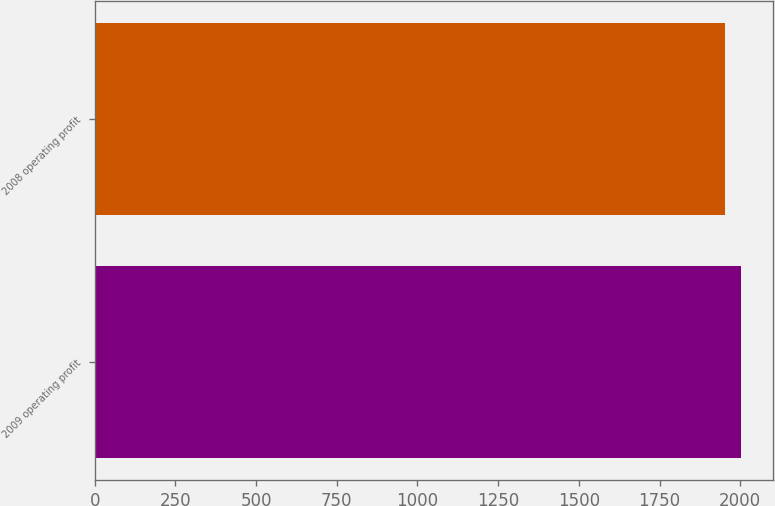<chart> <loc_0><loc_0><loc_500><loc_500><bar_chart><fcel>2009 operating profit<fcel>2008 operating profit<nl><fcel>2001<fcel>1953<nl></chart> 